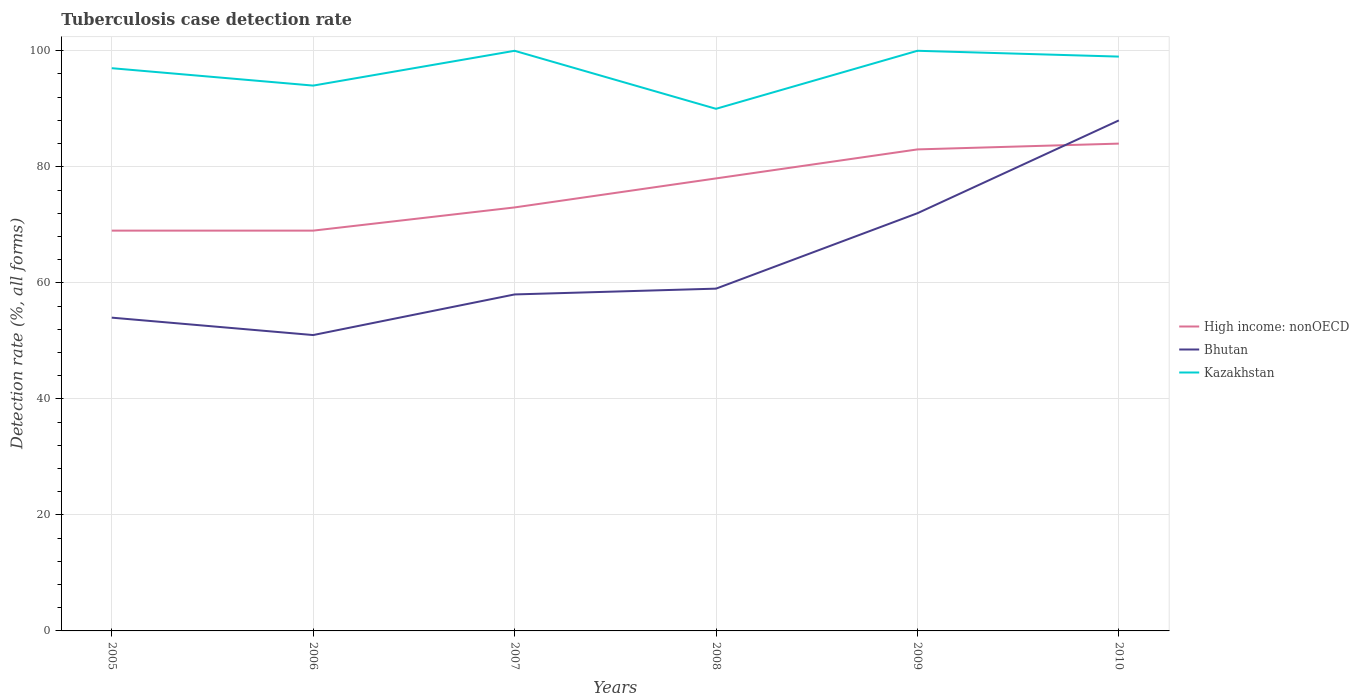How many different coloured lines are there?
Provide a short and direct response. 3. In which year was the tuberculosis case detection rate in in Bhutan maximum?
Make the answer very short. 2006. What is the total tuberculosis case detection rate in in Bhutan in the graph?
Ensure brevity in your answer.  -29. How many lines are there?
Offer a very short reply. 3. Does the graph contain grids?
Your answer should be compact. Yes. Where does the legend appear in the graph?
Provide a succinct answer. Center right. What is the title of the graph?
Your response must be concise. Tuberculosis case detection rate. Does "Bhutan" appear as one of the legend labels in the graph?
Your answer should be compact. Yes. What is the label or title of the X-axis?
Offer a very short reply. Years. What is the label or title of the Y-axis?
Ensure brevity in your answer.  Detection rate (%, all forms). What is the Detection rate (%, all forms) in High income: nonOECD in 2005?
Your answer should be compact. 69. What is the Detection rate (%, all forms) of Bhutan in 2005?
Offer a terse response. 54. What is the Detection rate (%, all forms) in Kazakhstan in 2005?
Ensure brevity in your answer.  97. What is the Detection rate (%, all forms) in High income: nonOECD in 2006?
Make the answer very short. 69. What is the Detection rate (%, all forms) of Kazakhstan in 2006?
Keep it short and to the point. 94. What is the Detection rate (%, all forms) in Bhutan in 2007?
Your answer should be compact. 58. What is the Detection rate (%, all forms) in Kazakhstan in 2007?
Offer a very short reply. 100. What is the Detection rate (%, all forms) of High income: nonOECD in 2008?
Offer a very short reply. 78. What is the Detection rate (%, all forms) in Bhutan in 2008?
Your answer should be compact. 59. What is the Detection rate (%, all forms) of Kazakhstan in 2008?
Make the answer very short. 90. What is the Detection rate (%, all forms) of High income: nonOECD in 2010?
Provide a succinct answer. 84. What is the Detection rate (%, all forms) of Bhutan in 2010?
Offer a very short reply. 88. Across all years, what is the minimum Detection rate (%, all forms) in Bhutan?
Offer a very short reply. 51. Across all years, what is the minimum Detection rate (%, all forms) of Kazakhstan?
Your response must be concise. 90. What is the total Detection rate (%, all forms) of High income: nonOECD in the graph?
Provide a short and direct response. 456. What is the total Detection rate (%, all forms) in Bhutan in the graph?
Ensure brevity in your answer.  382. What is the total Detection rate (%, all forms) of Kazakhstan in the graph?
Provide a short and direct response. 580. What is the difference between the Detection rate (%, all forms) in Kazakhstan in 2005 and that in 2006?
Make the answer very short. 3. What is the difference between the Detection rate (%, all forms) in High income: nonOECD in 2005 and that in 2007?
Your answer should be compact. -4. What is the difference between the Detection rate (%, all forms) of Kazakhstan in 2005 and that in 2007?
Keep it short and to the point. -3. What is the difference between the Detection rate (%, all forms) in Bhutan in 2005 and that in 2008?
Make the answer very short. -5. What is the difference between the Detection rate (%, all forms) of Bhutan in 2005 and that in 2010?
Provide a succinct answer. -34. What is the difference between the Detection rate (%, all forms) of High income: nonOECD in 2006 and that in 2008?
Provide a short and direct response. -9. What is the difference between the Detection rate (%, all forms) of Bhutan in 2006 and that in 2008?
Your answer should be compact. -8. What is the difference between the Detection rate (%, all forms) of Kazakhstan in 2006 and that in 2008?
Your response must be concise. 4. What is the difference between the Detection rate (%, all forms) in High income: nonOECD in 2006 and that in 2009?
Give a very brief answer. -14. What is the difference between the Detection rate (%, all forms) in Bhutan in 2006 and that in 2009?
Your answer should be very brief. -21. What is the difference between the Detection rate (%, all forms) in Bhutan in 2006 and that in 2010?
Offer a very short reply. -37. What is the difference between the Detection rate (%, all forms) in Kazakhstan in 2006 and that in 2010?
Make the answer very short. -5. What is the difference between the Detection rate (%, all forms) in High income: nonOECD in 2007 and that in 2008?
Your response must be concise. -5. What is the difference between the Detection rate (%, all forms) of Bhutan in 2007 and that in 2008?
Your response must be concise. -1. What is the difference between the Detection rate (%, all forms) of High income: nonOECD in 2008 and that in 2010?
Make the answer very short. -6. What is the difference between the Detection rate (%, all forms) in Bhutan in 2009 and that in 2010?
Offer a very short reply. -16. What is the difference between the Detection rate (%, all forms) in High income: nonOECD in 2005 and the Detection rate (%, all forms) in Kazakhstan in 2006?
Provide a succinct answer. -25. What is the difference between the Detection rate (%, all forms) in High income: nonOECD in 2005 and the Detection rate (%, all forms) in Kazakhstan in 2007?
Offer a terse response. -31. What is the difference between the Detection rate (%, all forms) in Bhutan in 2005 and the Detection rate (%, all forms) in Kazakhstan in 2007?
Offer a very short reply. -46. What is the difference between the Detection rate (%, all forms) in High income: nonOECD in 2005 and the Detection rate (%, all forms) in Kazakhstan in 2008?
Give a very brief answer. -21. What is the difference between the Detection rate (%, all forms) of Bhutan in 2005 and the Detection rate (%, all forms) of Kazakhstan in 2008?
Keep it short and to the point. -36. What is the difference between the Detection rate (%, all forms) of High income: nonOECD in 2005 and the Detection rate (%, all forms) of Kazakhstan in 2009?
Offer a terse response. -31. What is the difference between the Detection rate (%, all forms) of Bhutan in 2005 and the Detection rate (%, all forms) of Kazakhstan in 2009?
Provide a succinct answer. -46. What is the difference between the Detection rate (%, all forms) in High income: nonOECD in 2005 and the Detection rate (%, all forms) in Bhutan in 2010?
Give a very brief answer. -19. What is the difference between the Detection rate (%, all forms) of Bhutan in 2005 and the Detection rate (%, all forms) of Kazakhstan in 2010?
Give a very brief answer. -45. What is the difference between the Detection rate (%, all forms) of High income: nonOECD in 2006 and the Detection rate (%, all forms) of Kazakhstan in 2007?
Your answer should be very brief. -31. What is the difference between the Detection rate (%, all forms) in Bhutan in 2006 and the Detection rate (%, all forms) in Kazakhstan in 2007?
Ensure brevity in your answer.  -49. What is the difference between the Detection rate (%, all forms) in Bhutan in 2006 and the Detection rate (%, all forms) in Kazakhstan in 2008?
Give a very brief answer. -39. What is the difference between the Detection rate (%, all forms) of High income: nonOECD in 2006 and the Detection rate (%, all forms) of Kazakhstan in 2009?
Your answer should be compact. -31. What is the difference between the Detection rate (%, all forms) in Bhutan in 2006 and the Detection rate (%, all forms) in Kazakhstan in 2009?
Offer a terse response. -49. What is the difference between the Detection rate (%, all forms) of High income: nonOECD in 2006 and the Detection rate (%, all forms) of Kazakhstan in 2010?
Make the answer very short. -30. What is the difference between the Detection rate (%, all forms) in Bhutan in 2006 and the Detection rate (%, all forms) in Kazakhstan in 2010?
Ensure brevity in your answer.  -48. What is the difference between the Detection rate (%, all forms) of High income: nonOECD in 2007 and the Detection rate (%, all forms) of Bhutan in 2008?
Ensure brevity in your answer.  14. What is the difference between the Detection rate (%, all forms) in High income: nonOECD in 2007 and the Detection rate (%, all forms) in Kazakhstan in 2008?
Give a very brief answer. -17. What is the difference between the Detection rate (%, all forms) in Bhutan in 2007 and the Detection rate (%, all forms) in Kazakhstan in 2008?
Ensure brevity in your answer.  -32. What is the difference between the Detection rate (%, all forms) in High income: nonOECD in 2007 and the Detection rate (%, all forms) in Bhutan in 2009?
Make the answer very short. 1. What is the difference between the Detection rate (%, all forms) of Bhutan in 2007 and the Detection rate (%, all forms) of Kazakhstan in 2009?
Give a very brief answer. -42. What is the difference between the Detection rate (%, all forms) in High income: nonOECD in 2007 and the Detection rate (%, all forms) in Kazakhstan in 2010?
Offer a terse response. -26. What is the difference between the Detection rate (%, all forms) in Bhutan in 2007 and the Detection rate (%, all forms) in Kazakhstan in 2010?
Provide a short and direct response. -41. What is the difference between the Detection rate (%, all forms) in High income: nonOECD in 2008 and the Detection rate (%, all forms) in Bhutan in 2009?
Make the answer very short. 6. What is the difference between the Detection rate (%, all forms) of High income: nonOECD in 2008 and the Detection rate (%, all forms) of Kazakhstan in 2009?
Offer a terse response. -22. What is the difference between the Detection rate (%, all forms) of Bhutan in 2008 and the Detection rate (%, all forms) of Kazakhstan in 2009?
Make the answer very short. -41. What is the difference between the Detection rate (%, all forms) of Bhutan in 2008 and the Detection rate (%, all forms) of Kazakhstan in 2010?
Offer a terse response. -40. What is the difference between the Detection rate (%, all forms) of High income: nonOECD in 2009 and the Detection rate (%, all forms) of Bhutan in 2010?
Your answer should be compact. -5. What is the average Detection rate (%, all forms) in Bhutan per year?
Your answer should be very brief. 63.67. What is the average Detection rate (%, all forms) of Kazakhstan per year?
Keep it short and to the point. 96.67. In the year 2005, what is the difference between the Detection rate (%, all forms) in High income: nonOECD and Detection rate (%, all forms) in Bhutan?
Ensure brevity in your answer.  15. In the year 2005, what is the difference between the Detection rate (%, all forms) in Bhutan and Detection rate (%, all forms) in Kazakhstan?
Your answer should be compact. -43. In the year 2006, what is the difference between the Detection rate (%, all forms) of High income: nonOECD and Detection rate (%, all forms) of Kazakhstan?
Provide a succinct answer. -25. In the year 2006, what is the difference between the Detection rate (%, all forms) of Bhutan and Detection rate (%, all forms) of Kazakhstan?
Make the answer very short. -43. In the year 2007, what is the difference between the Detection rate (%, all forms) in Bhutan and Detection rate (%, all forms) in Kazakhstan?
Ensure brevity in your answer.  -42. In the year 2008, what is the difference between the Detection rate (%, all forms) in Bhutan and Detection rate (%, all forms) in Kazakhstan?
Offer a terse response. -31. In the year 2009, what is the difference between the Detection rate (%, all forms) of High income: nonOECD and Detection rate (%, all forms) of Bhutan?
Provide a short and direct response. 11. In the year 2009, what is the difference between the Detection rate (%, all forms) in Bhutan and Detection rate (%, all forms) in Kazakhstan?
Your response must be concise. -28. In the year 2010, what is the difference between the Detection rate (%, all forms) of High income: nonOECD and Detection rate (%, all forms) of Bhutan?
Make the answer very short. -4. What is the ratio of the Detection rate (%, all forms) in High income: nonOECD in 2005 to that in 2006?
Offer a very short reply. 1. What is the ratio of the Detection rate (%, all forms) of Bhutan in 2005 to that in 2006?
Offer a terse response. 1.06. What is the ratio of the Detection rate (%, all forms) of Kazakhstan in 2005 to that in 2006?
Offer a very short reply. 1.03. What is the ratio of the Detection rate (%, all forms) of High income: nonOECD in 2005 to that in 2007?
Offer a terse response. 0.95. What is the ratio of the Detection rate (%, all forms) in Bhutan in 2005 to that in 2007?
Keep it short and to the point. 0.93. What is the ratio of the Detection rate (%, all forms) of High income: nonOECD in 2005 to that in 2008?
Provide a succinct answer. 0.88. What is the ratio of the Detection rate (%, all forms) in Bhutan in 2005 to that in 2008?
Make the answer very short. 0.92. What is the ratio of the Detection rate (%, all forms) in Kazakhstan in 2005 to that in 2008?
Give a very brief answer. 1.08. What is the ratio of the Detection rate (%, all forms) in High income: nonOECD in 2005 to that in 2009?
Your response must be concise. 0.83. What is the ratio of the Detection rate (%, all forms) of Bhutan in 2005 to that in 2009?
Make the answer very short. 0.75. What is the ratio of the Detection rate (%, all forms) in High income: nonOECD in 2005 to that in 2010?
Provide a short and direct response. 0.82. What is the ratio of the Detection rate (%, all forms) of Bhutan in 2005 to that in 2010?
Your answer should be very brief. 0.61. What is the ratio of the Detection rate (%, all forms) in Kazakhstan in 2005 to that in 2010?
Make the answer very short. 0.98. What is the ratio of the Detection rate (%, all forms) in High income: nonOECD in 2006 to that in 2007?
Offer a very short reply. 0.95. What is the ratio of the Detection rate (%, all forms) of Bhutan in 2006 to that in 2007?
Offer a very short reply. 0.88. What is the ratio of the Detection rate (%, all forms) in High income: nonOECD in 2006 to that in 2008?
Provide a short and direct response. 0.88. What is the ratio of the Detection rate (%, all forms) in Bhutan in 2006 to that in 2008?
Make the answer very short. 0.86. What is the ratio of the Detection rate (%, all forms) in Kazakhstan in 2006 to that in 2008?
Offer a terse response. 1.04. What is the ratio of the Detection rate (%, all forms) of High income: nonOECD in 2006 to that in 2009?
Provide a succinct answer. 0.83. What is the ratio of the Detection rate (%, all forms) in Bhutan in 2006 to that in 2009?
Provide a short and direct response. 0.71. What is the ratio of the Detection rate (%, all forms) in High income: nonOECD in 2006 to that in 2010?
Provide a succinct answer. 0.82. What is the ratio of the Detection rate (%, all forms) of Bhutan in 2006 to that in 2010?
Make the answer very short. 0.58. What is the ratio of the Detection rate (%, all forms) in Kazakhstan in 2006 to that in 2010?
Give a very brief answer. 0.95. What is the ratio of the Detection rate (%, all forms) of High income: nonOECD in 2007 to that in 2008?
Provide a short and direct response. 0.94. What is the ratio of the Detection rate (%, all forms) in Bhutan in 2007 to that in 2008?
Your answer should be very brief. 0.98. What is the ratio of the Detection rate (%, all forms) of High income: nonOECD in 2007 to that in 2009?
Offer a terse response. 0.88. What is the ratio of the Detection rate (%, all forms) of Bhutan in 2007 to that in 2009?
Offer a terse response. 0.81. What is the ratio of the Detection rate (%, all forms) of High income: nonOECD in 2007 to that in 2010?
Your response must be concise. 0.87. What is the ratio of the Detection rate (%, all forms) in Bhutan in 2007 to that in 2010?
Provide a short and direct response. 0.66. What is the ratio of the Detection rate (%, all forms) in High income: nonOECD in 2008 to that in 2009?
Make the answer very short. 0.94. What is the ratio of the Detection rate (%, all forms) in Bhutan in 2008 to that in 2009?
Your answer should be compact. 0.82. What is the ratio of the Detection rate (%, all forms) of Kazakhstan in 2008 to that in 2009?
Provide a succinct answer. 0.9. What is the ratio of the Detection rate (%, all forms) of Bhutan in 2008 to that in 2010?
Offer a very short reply. 0.67. What is the ratio of the Detection rate (%, all forms) in High income: nonOECD in 2009 to that in 2010?
Provide a succinct answer. 0.99. What is the ratio of the Detection rate (%, all forms) in Bhutan in 2009 to that in 2010?
Offer a very short reply. 0.82. What is the ratio of the Detection rate (%, all forms) of Kazakhstan in 2009 to that in 2010?
Your response must be concise. 1.01. What is the difference between the highest and the second highest Detection rate (%, all forms) of High income: nonOECD?
Ensure brevity in your answer.  1. What is the difference between the highest and the second highest Detection rate (%, all forms) in Bhutan?
Make the answer very short. 16. 